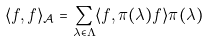<formula> <loc_0><loc_0><loc_500><loc_500>\langle f , f \rangle _ { \mathcal { A } } = \sum _ { \lambda \in \Lambda } \langle f , \pi ( \lambda ) f \rangle \pi ( \lambda )</formula> 